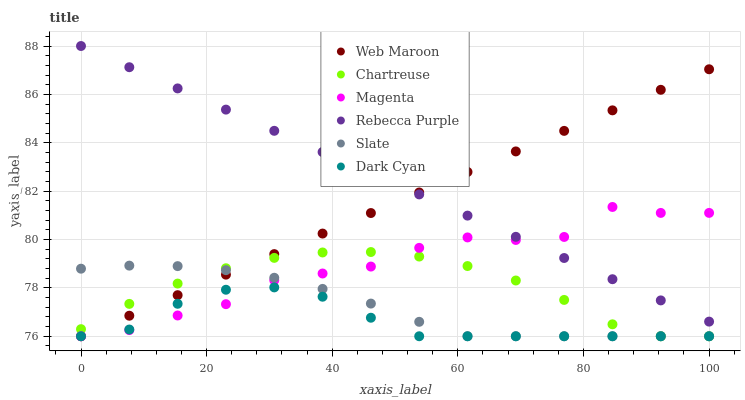Does Dark Cyan have the minimum area under the curve?
Answer yes or no. Yes. Does Rebecca Purple have the maximum area under the curve?
Answer yes or no. Yes. Does Web Maroon have the minimum area under the curve?
Answer yes or no. No. Does Web Maroon have the maximum area under the curve?
Answer yes or no. No. Is Rebecca Purple the smoothest?
Answer yes or no. Yes. Is Magenta the roughest?
Answer yes or no. Yes. Is Web Maroon the smoothest?
Answer yes or no. No. Is Web Maroon the roughest?
Answer yes or no. No. Does Slate have the lowest value?
Answer yes or no. Yes. Does Rebecca Purple have the lowest value?
Answer yes or no. No. Does Rebecca Purple have the highest value?
Answer yes or no. Yes. Does Web Maroon have the highest value?
Answer yes or no. No. Is Chartreuse less than Rebecca Purple?
Answer yes or no. Yes. Is Rebecca Purple greater than Slate?
Answer yes or no. Yes. Does Chartreuse intersect Slate?
Answer yes or no. Yes. Is Chartreuse less than Slate?
Answer yes or no. No. Is Chartreuse greater than Slate?
Answer yes or no. No. Does Chartreuse intersect Rebecca Purple?
Answer yes or no. No. 